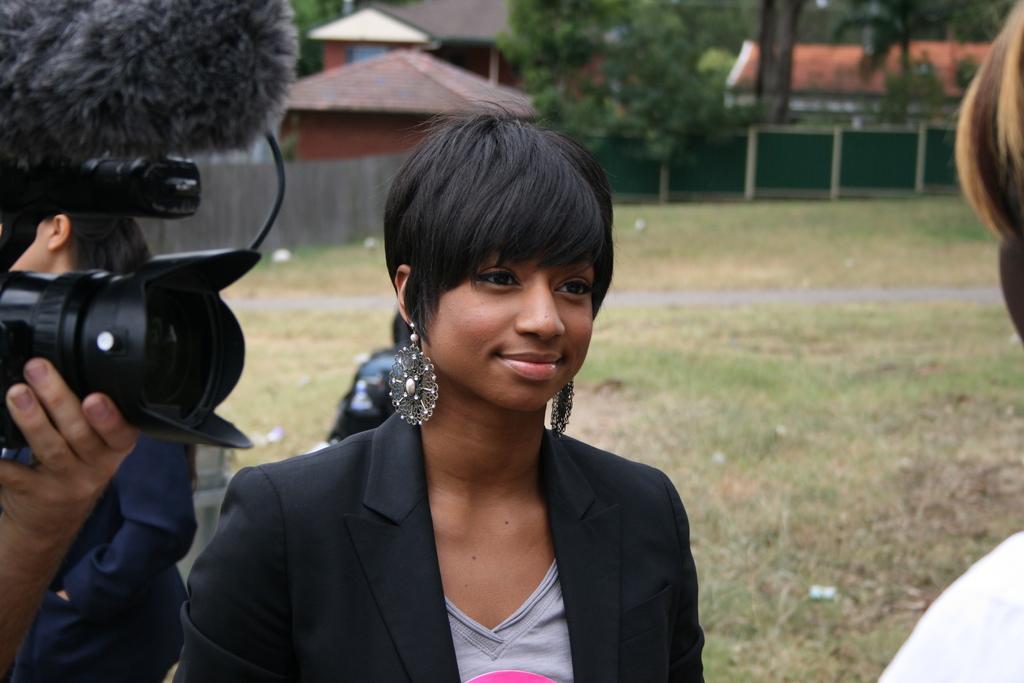In one or two sentences, can you explain what this image depicts? a lady with black color jacket is standing and smiling. To the right side there is a man standing. And to the left side there is a person holding a camera in his hand. In the background there are houses with roof on it and also some trees. We can see a green color fencing. 